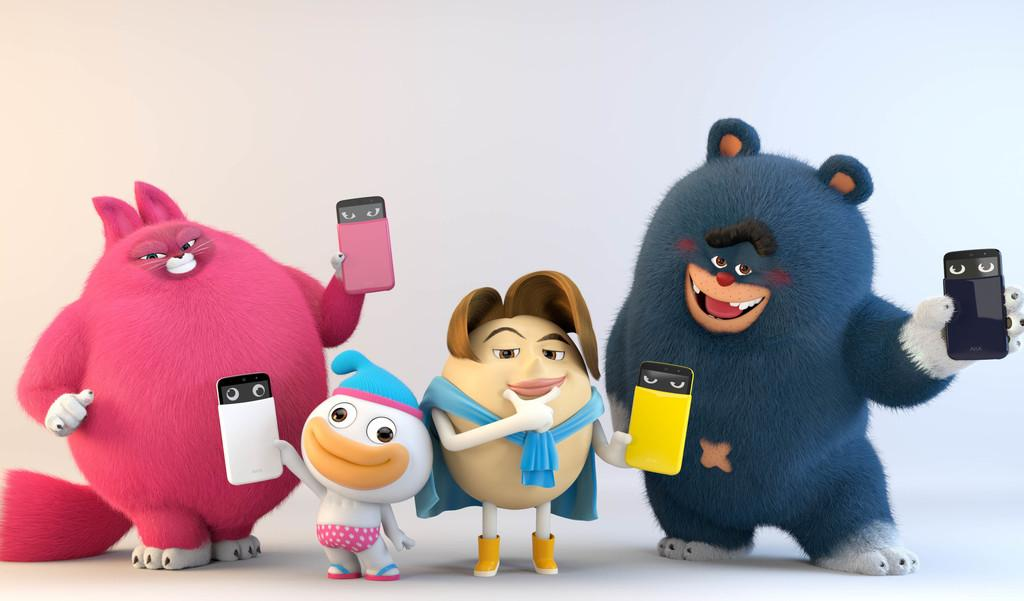What can be seen in the image? There are toys in the image. What are the toys doing in the image? The toys are holding an object. What type of respect can be seen being shown by the toys in the image? There is no indication of respect being shown in the image, as it features toys holding an object. What type of bulb is being used by the toys in the image? There is no bulb present in the image; it features toys holding an object. 